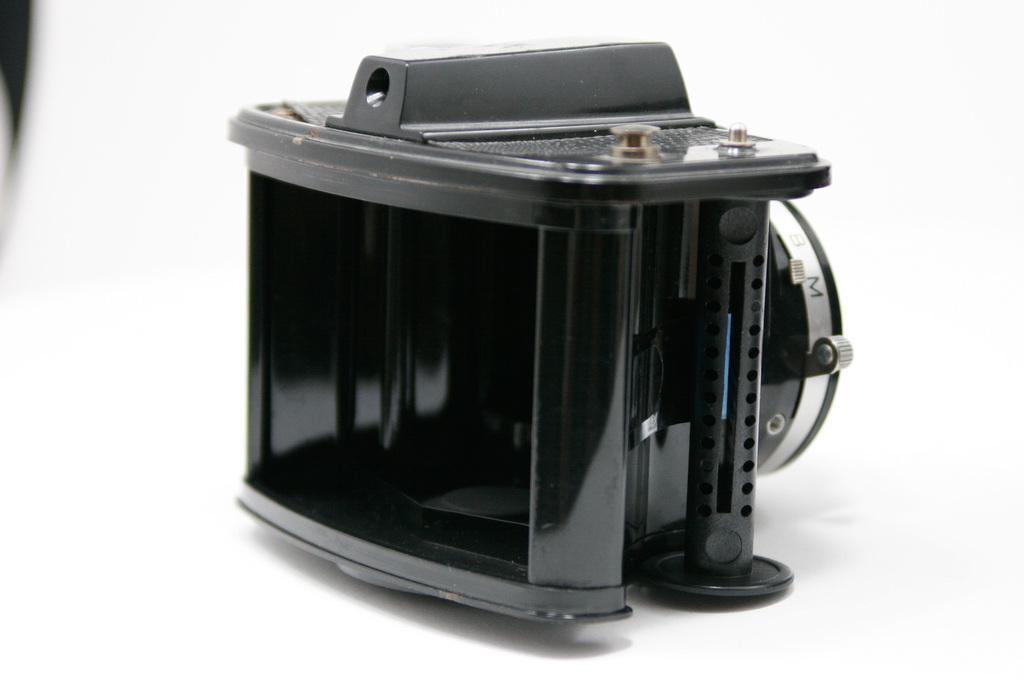What is the main color of the object in the image? The main color of the object in the image is black. What is the object placed on in the image? The black object is on a white surface. What is the color of the background in the image? The background of the image is white in color. What religious symbol can be seen in the image? There is no religious symbol present in the image. How is the image divided into sections? The image is not divided into sections; it is a single, continuous image. 